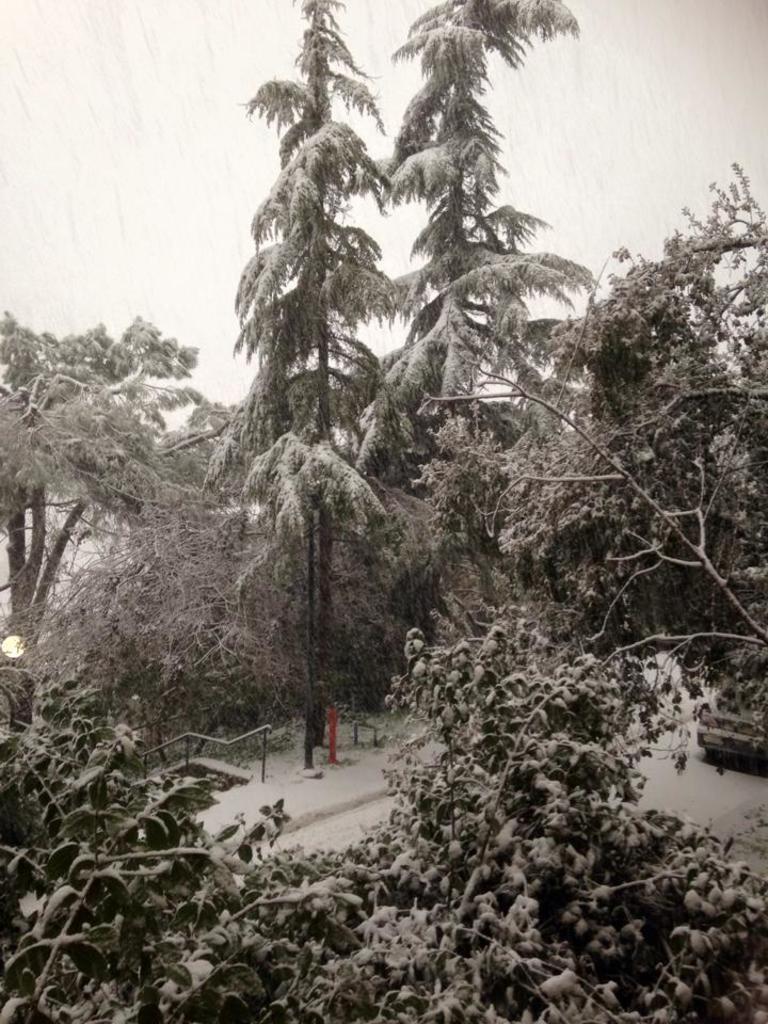How would you summarize this image in a sentence or two? In the picture I can see trees and some other objects on the ground. This picture is black and white in color. 